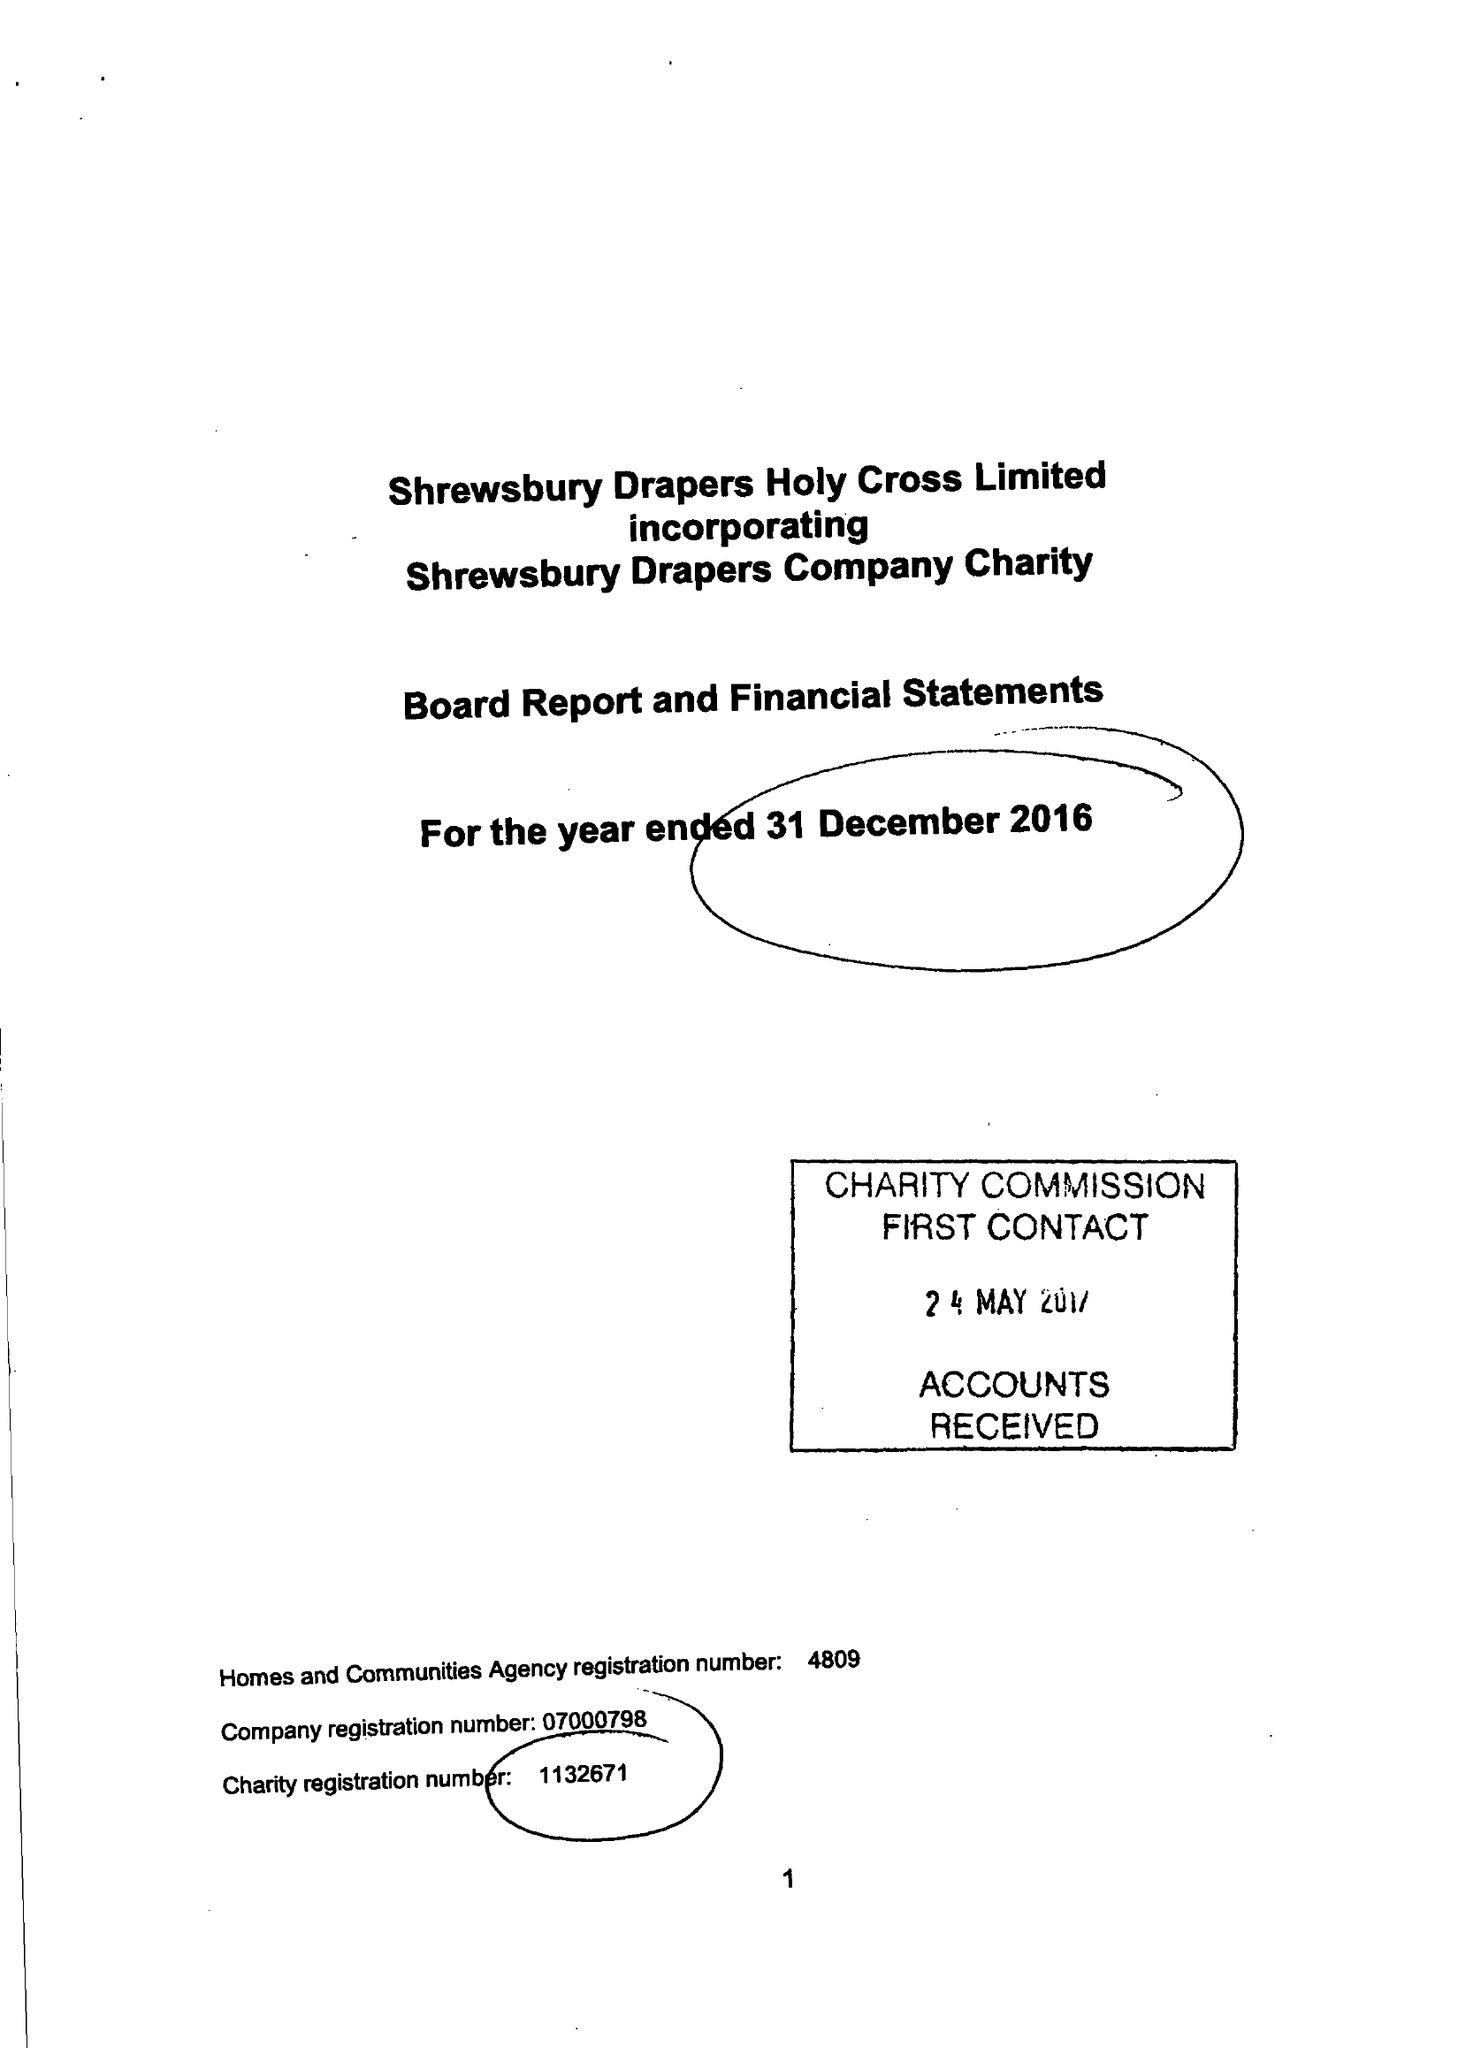What is the value for the income_annually_in_british_pounds?
Answer the question using a single word or phrase. 1424124.00 